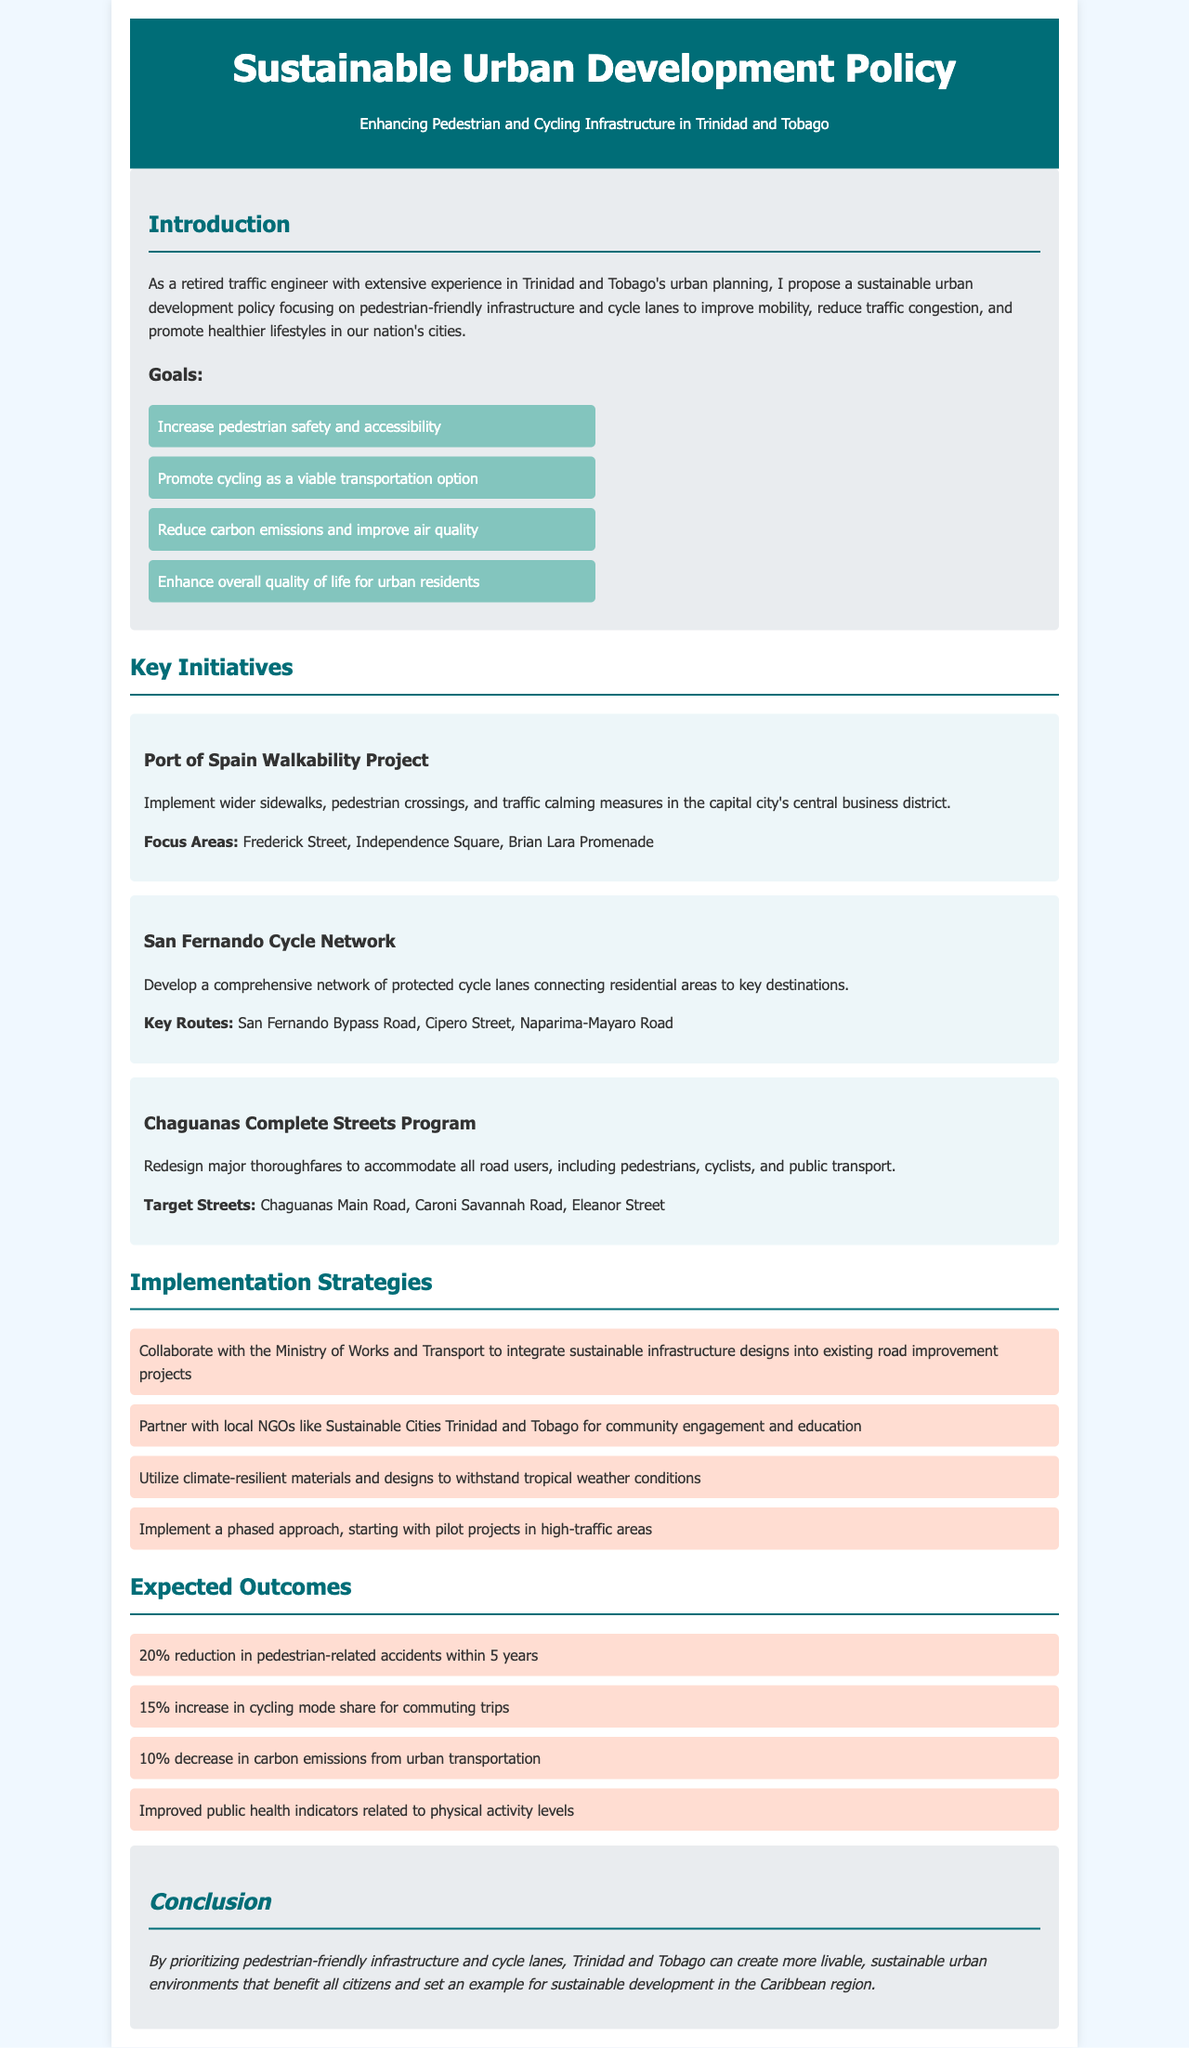What is the main focus of the proposed policy? The main focus of the proposed policy is enhancing pedestrian-friendly infrastructure and cycle lanes.
Answer: pedestrian-friendly infrastructure and cycle lanes How many goals are listed in the document? The document lists four goals in total.
Answer: four What is one of the key routes in the San Fernando Cycle Network? The document specifies San Fernando Bypass Road as one of the key routes.
Answer: San Fernando Bypass Road What is the expected percentage reduction in pedestrian-related accidents within 5 years? The document states an expected reduction of 20% in pedestrian-related accidents within 5 years.
Answer: 20% Which major thoroughfare is targeted in the Chaguanas Complete Streets Program? Chaguanas Main Road is mentioned as a targeted thoroughfare in the program.
Answer: Chaguanas Main Road What type of organizations does the document suggest partnering with for community engagement? Local NGOs like Sustainable Cities Trinidad and Tobago are suggested for partnership.
Answer: Sustainable Cities Trinidad and Tobago What is one expected outcome regarding carbon emissions? The document mentions a 10% decrease in carbon emissions from urban transportation.
Answer: 10% Which city is the focus of the Walkability Project? The document indicates that Port of Spain is the focus city for the Walkability Project.
Answer: Port of Spain 